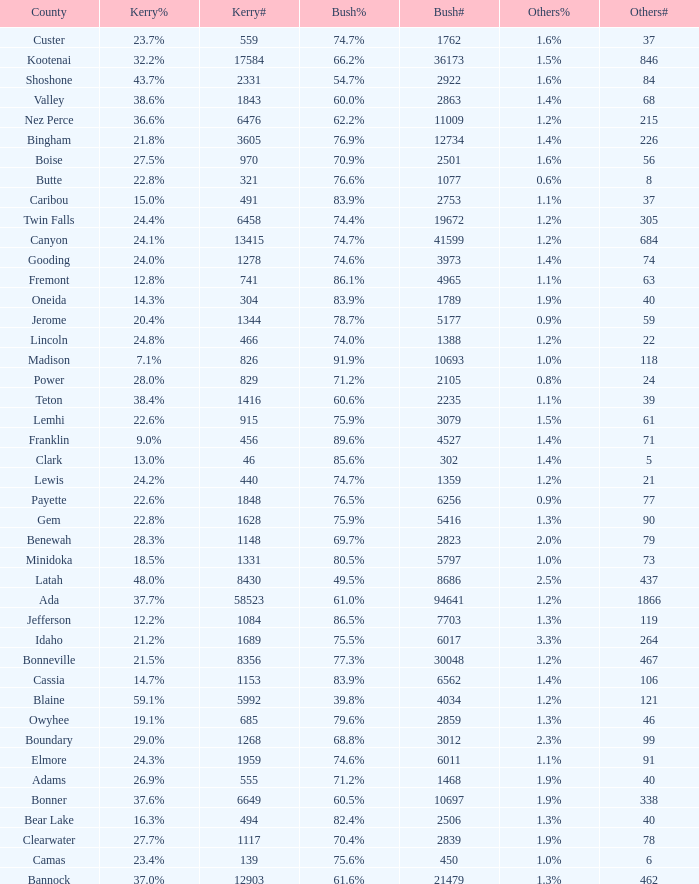How many people voted for Kerry in the county where 8 voted for others? 321.0. 